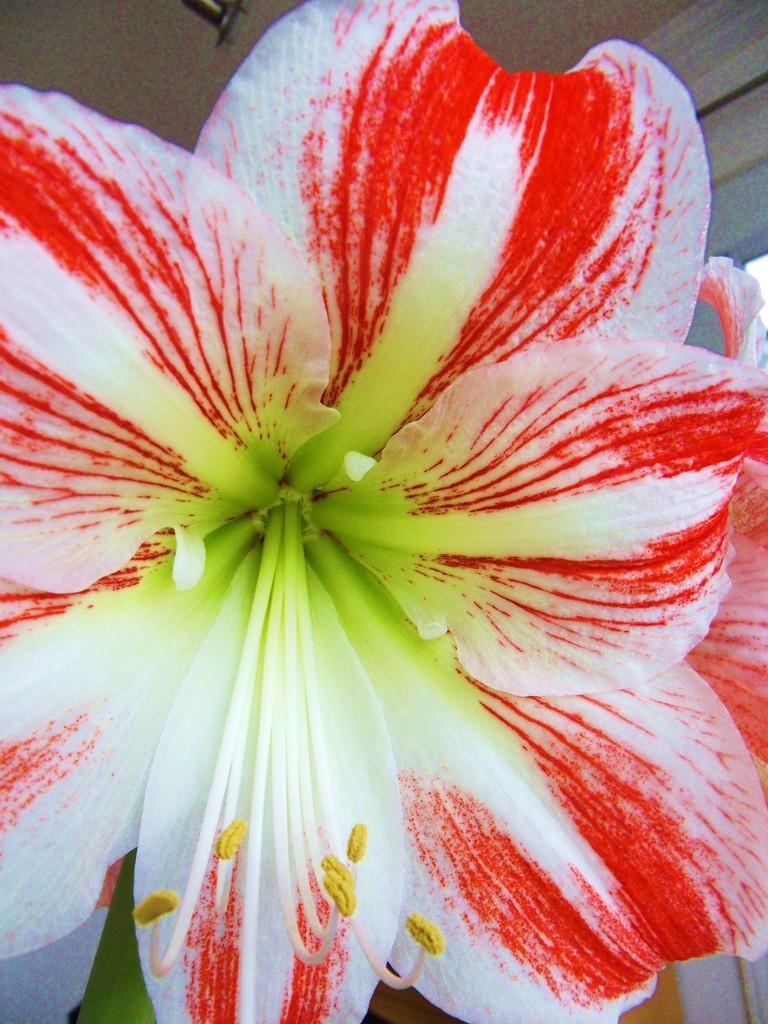Could you give a brief overview of what you see in this image? This picture shows a couple of flowers and the color of the flowers is white and red. 